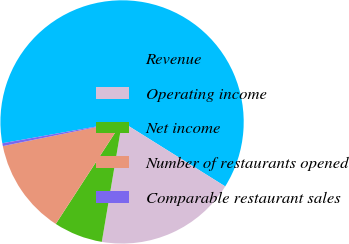Convert chart to OTSL. <chart><loc_0><loc_0><loc_500><loc_500><pie_chart><fcel>Revenue<fcel>Operating income<fcel>Net income<fcel>Number of restaurants opened<fcel>Comparable restaurant sales<nl><fcel>61.69%<fcel>18.77%<fcel>6.51%<fcel>12.64%<fcel>0.38%<nl></chart> 